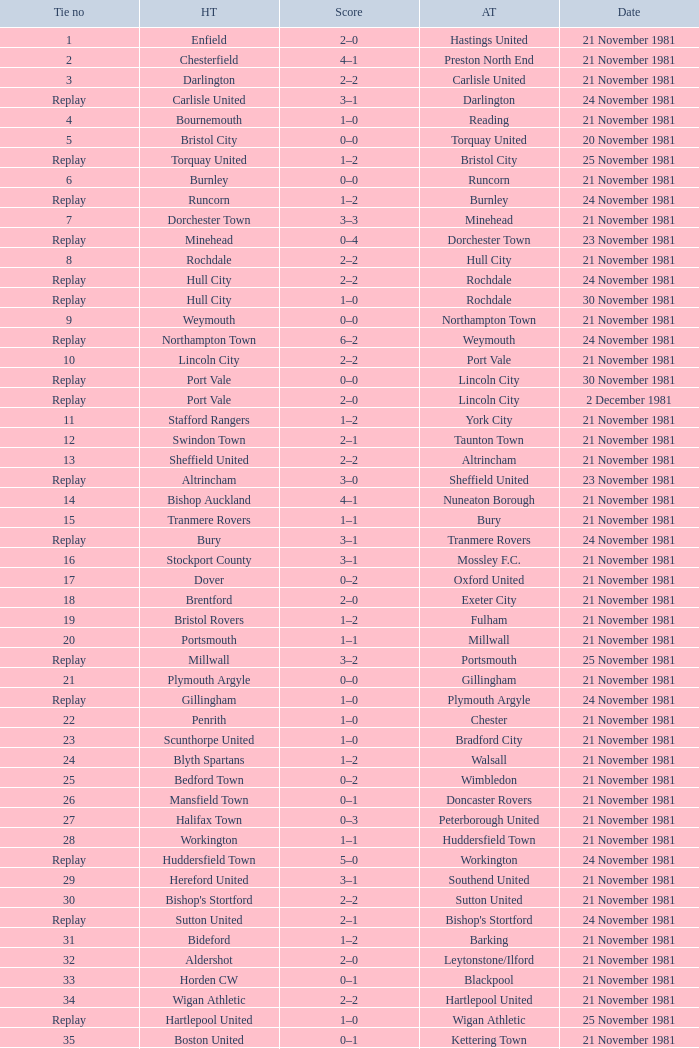What is enfield's tie number? 1.0. 